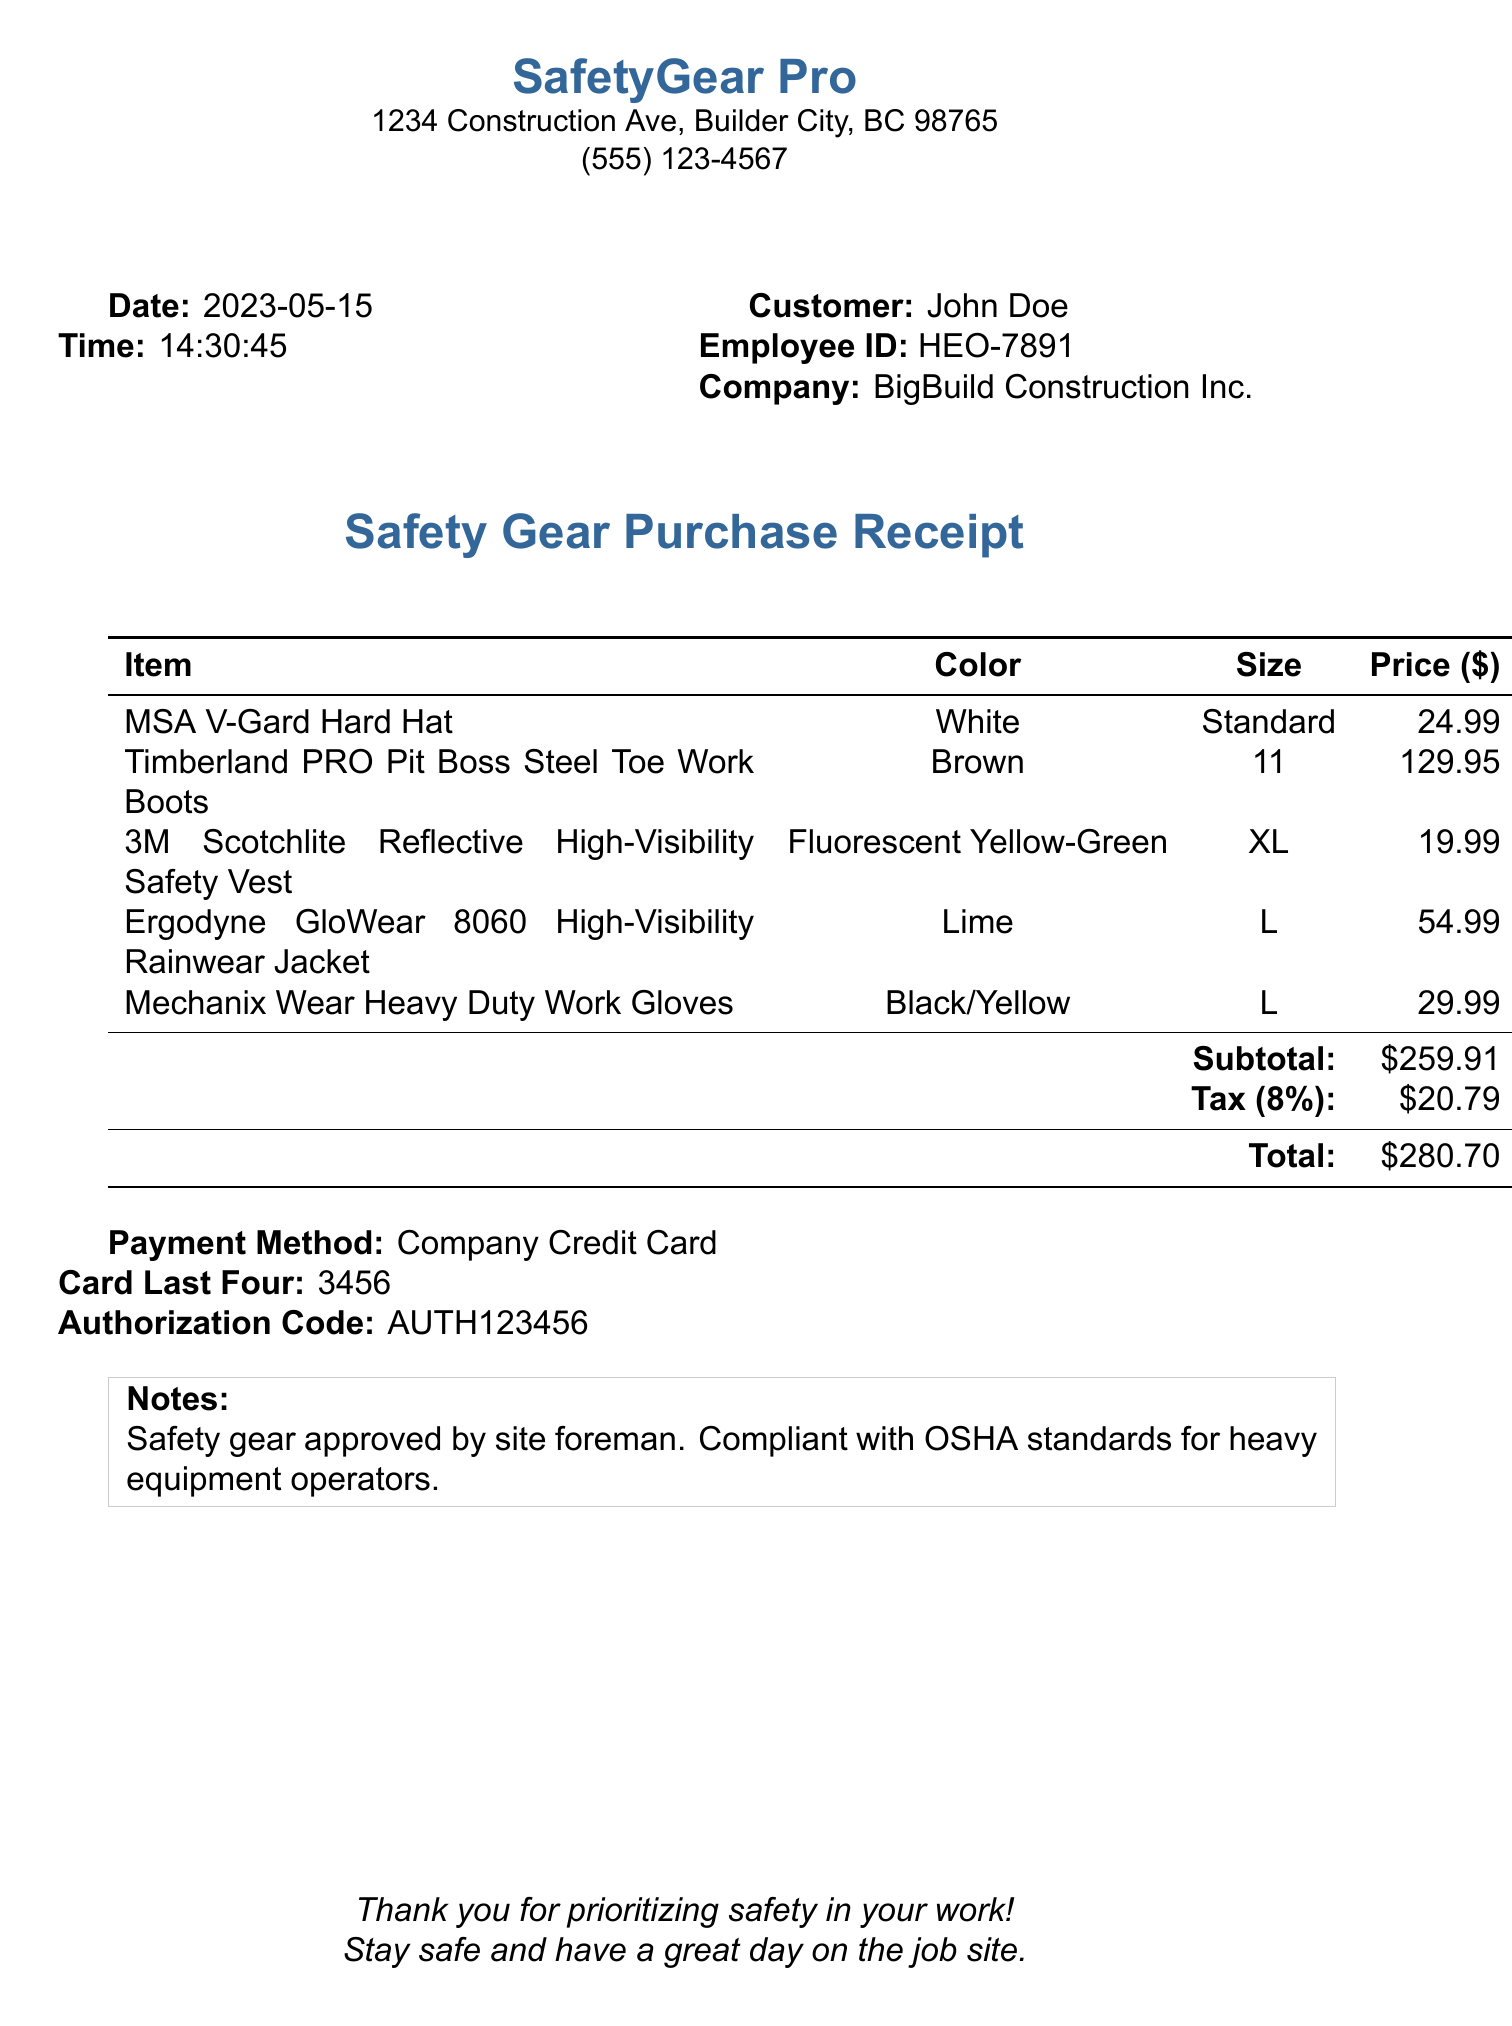What is the store name? The store name is listed at the top of the document as the location where the purchase was made.
Answer: SafetyGear Pro What is the date of purchase? The date of purchase is indicated in the receipt section detailing when the transaction occurred.
Answer: 2023-05-15 What is the price of the hard hat? The individual price of the hard hat is detailed in the items section alongside its description.
Answer: 24.99 How many items were purchased in total? The total number of items is calculated by summing up the quantities listed for each individual item.
Answer: 5 What is the total amount paid? The total amount is at the bottom of the receipt and includes the subtotal and tax.
Answer: 280.70 Which payment method was used? The payment method is mentioned in the payment details section of the receipt.
Answer: Company Credit Card What is the color of the high-visibility vest? The color of the high-visibility vest is specified in the item details section.
Answer: Fluorescent Yellow-Green What does the note indicate about the safety gear? The note at the bottom of the receipt provides information about the safety standards of the purchased gear.
Answer: Compliant with OSHA standards for heavy equipment operators 